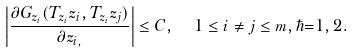<formula> <loc_0><loc_0><loc_500><loc_500>\left | \frac { \partial G _ { z _ { i } } ( T _ { z _ { i } } z _ { i } , T _ { z _ { i } } z _ { j } ) } { \partial z _ { i , } } \right | \leq C , \ \ 1 \leq i \neq j \leq m , \hbar { = } 1 , 2 .</formula> 